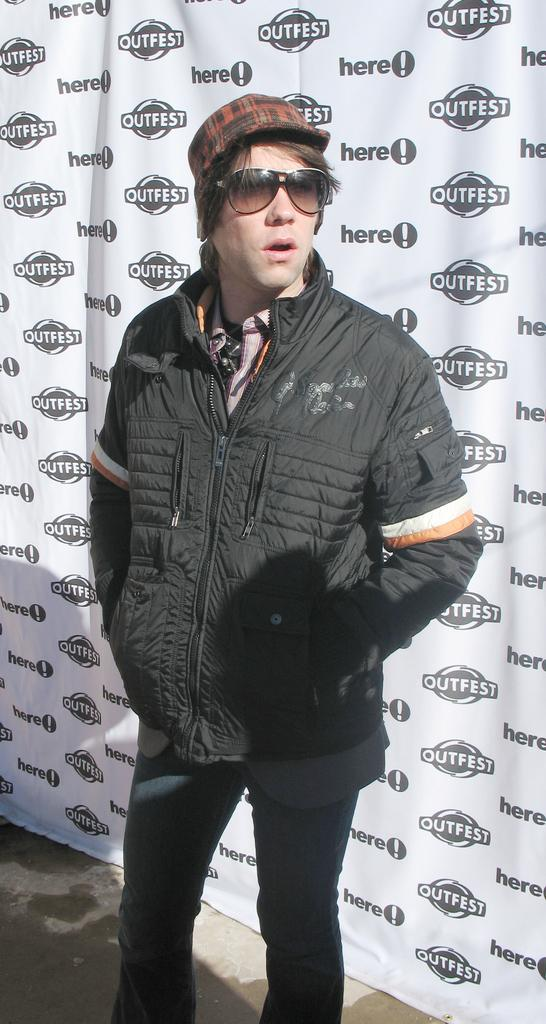Who is present in the image? There is a person in the image. What type of clothing is the person wearing? The person is wearing a jacket and a cap. What can be seen in the background of the image? There is a white color banner in the background of the image. What is written on the banner? The banner has some text on it. What type of breakfast is the person eating in the image? There is no breakfast present in the image; it only shows a person wearing a jacket and cap with a banner in the background. Can you tell me the order of the items on the banner? The order of the items on the banner cannot be determined from the image, as only the presence of text is mentioned. 